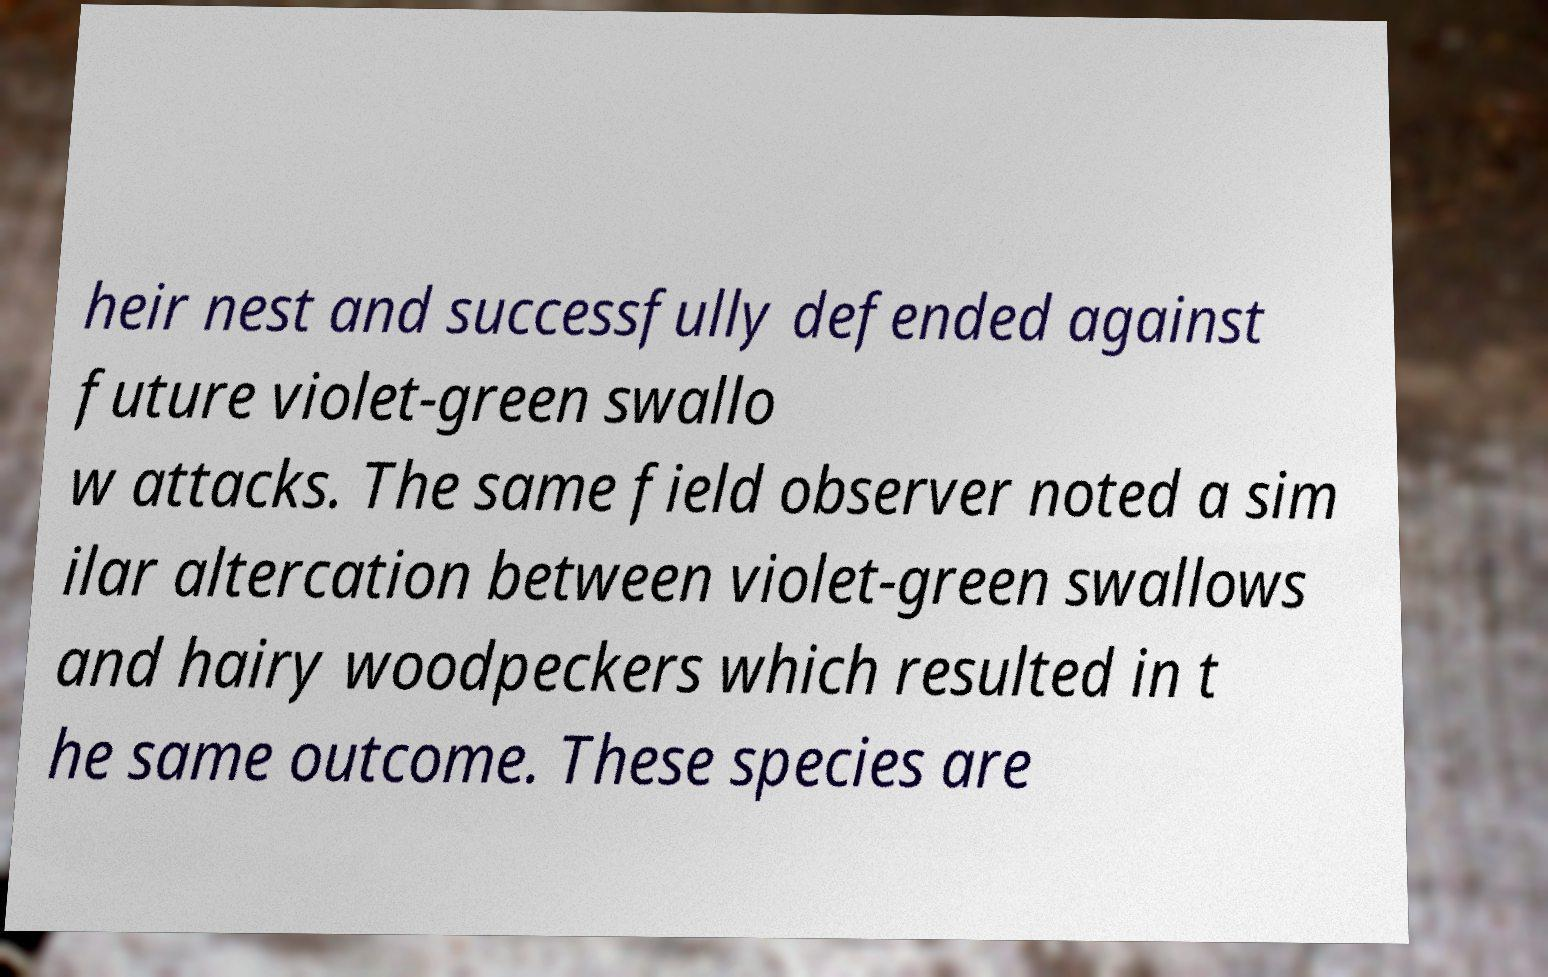There's text embedded in this image that I need extracted. Can you transcribe it verbatim? heir nest and successfully defended against future violet-green swallo w attacks. The same field observer noted a sim ilar altercation between violet-green swallows and hairy woodpeckers which resulted in t he same outcome. These species are 